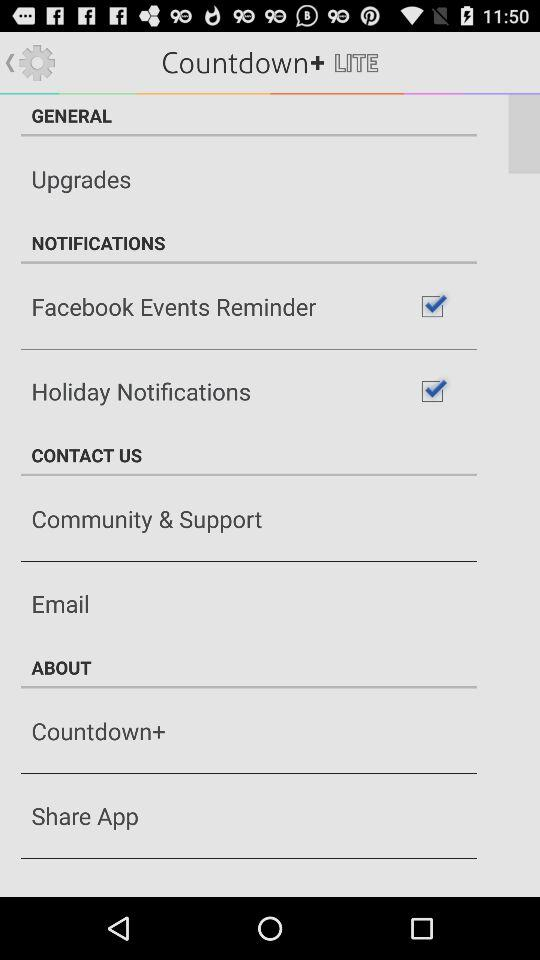What is the status of "Facebook Events Reminder"? The status is "on". 